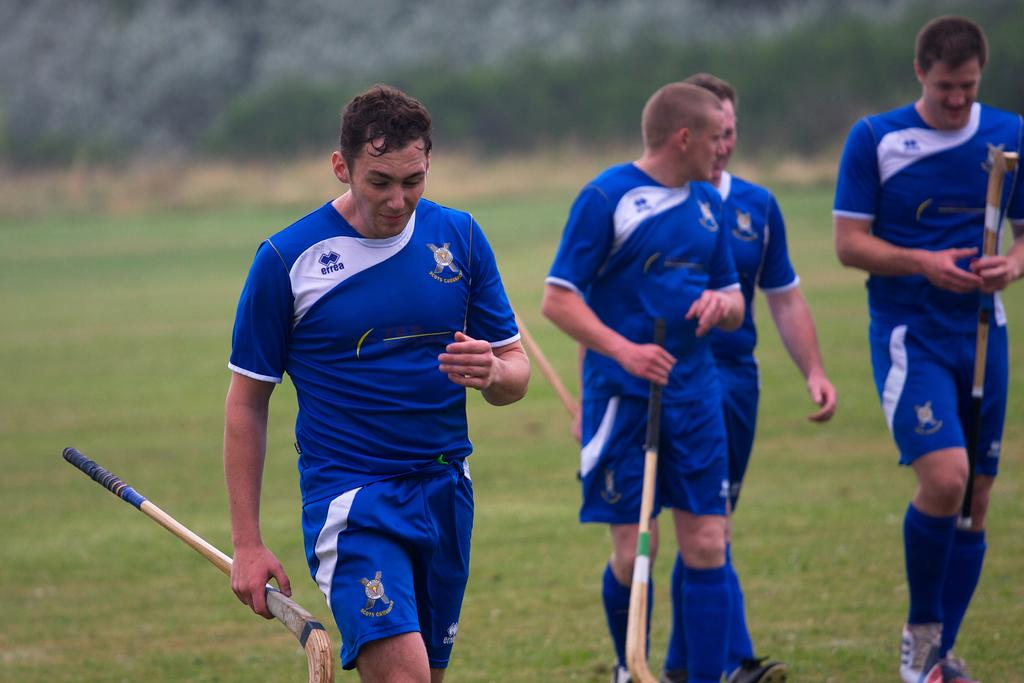How many people are in the image? There are four people in the image. What are the people holding in the image? The people are holding hockey sticks. What type of surface are the people walking on? The people are walking on a grass path. Can you describe the background of the image? The background of the image is blurred. What type of cabbage can be seen growing in the background of the image? There is no cabbage visible in the image, as the background is blurred. What time of day is it in the image, considering it is night? The image does not depict nighttime, as there is daylight visible in the sky. 